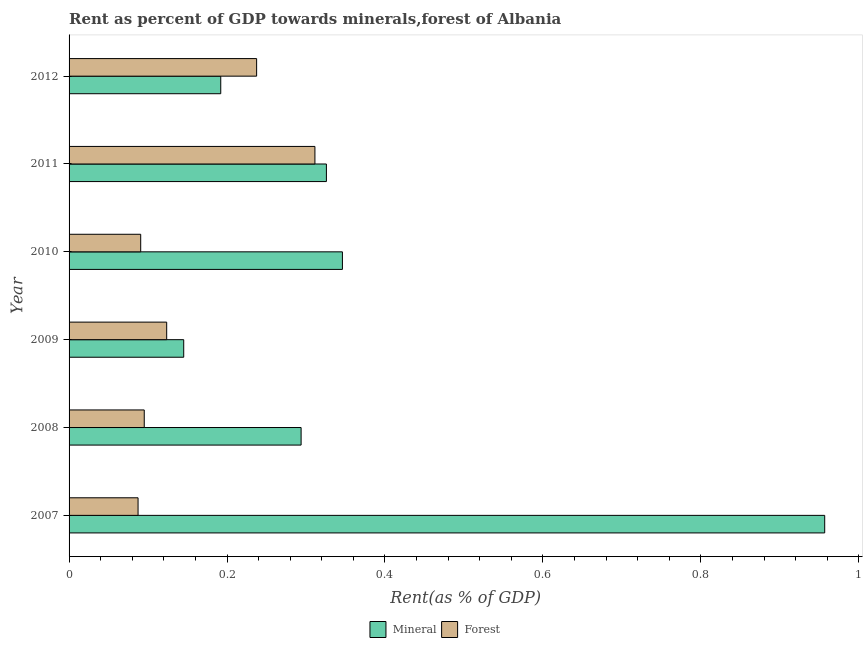How many different coloured bars are there?
Provide a succinct answer. 2. How many groups of bars are there?
Give a very brief answer. 6. Are the number of bars on each tick of the Y-axis equal?
Ensure brevity in your answer.  Yes. How many bars are there on the 3rd tick from the top?
Give a very brief answer. 2. How many bars are there on the 2nd tick from the bottom?
Ensure brevity in your answer.  2. In how many cases, is the number of bars for a given year not equal to the number of legend labels?
Your answer should be very brief. 0. What is the mineral rent in 2008?
Keep it short and to the point. 0.29. Across all years, what is the maximum forest rent?
Offer a terse response. 0.31. Across all years, what is the minimum mineral rent?
Your answer should be compact. 0.15. What is the total mineral rent in the graph?
Your response must be concise. 2.26. What is the difference between the forest rent in 2007 and that in 2012?
Your answer should be compact. -0.15. What is the difference between the mineral rent in 2012 and the forest rent in 2010?
Offer a terse response. 0.1. What is the average forest rent per year?
Offer a terse response. 0.16. In the year 2011, what is the difference between the mineral rent and forest rent?
Your answer should be compact. 0.01. What is the ratio of the mineral rent in 2008 to that in 2010?
Your answer should be compact. 0.85. Is the mineral rent in 2009 less than that in 2010?
Keep it short and to the point. Yes. Is the difference between the mineral rent in 2010 and 2012 greater than the difference between the forest rent in 2010 and 2012?
Offer a terse response. Yes. What is the difference between the highest and the second highest mineral rent?
Offer a very short reply. 0.61. What is the difference between the highest and the lowest mineral rent?
Provide a succinct answer. 0.81. In how many years, is the mineral rent greater than the average mineral rent taken over all years?
Offer a terse response. 1. Is the sum of the mineral rent in 2009 and 2012 greater than the maximum forest rent across all years?
Give a very brief answer. Yes. What does the 1st bar from the top in 2008 represents?
Your answer should be very brief. Forest. What does the 2nd bar from the bottom in 2008 represents?
Offer a very short reply. Forest. How many bars are there?
Your response must be concise. 12. How many years are there in the graph?
Offer a very short reply. 6. Are the values on the major ticks of X-axis written in scientific E-notation?
Ensure brevity in your answer.  No. Does the graph contain any zero values?
Ensure brevity in your answer.  No. Does the graph contain grids?
Make the answer very short. No. Where does the legend appear in the graph?
Give a very brief answer. Bottom center. How are the legend labels stacked?
Ensure brevity in your answer.  Horizontal. What is the title of the graph?
Keep it short and to the point. Rent as percent of GDP towards minerals,forest of Albania. What is the label or title of the X-axis?
Offer a very short reply. Rent(as % of GDP). What is the label or title of the Y-axis?
Your answer should be very brief. Year. What is the Rent(as % of GDP) in Mineral in 2007?
Provide a short and direct response. 0.96. What is the Rent(as % of GDP) of Forest in 2007?
Make the answer very short. 0.09. What is the Rent(as % of GDP) of Mineral in 2008?
Your response must be concise. 0.29. What is the Rent(as % of GDP) of Forest in 2008?
Your answer should be compact. 0.1. What is the Rent(as % of GDP) in Mineral in 2009?
Provide a short and direct response. 0.15. What is the Rent(as % of GDP) in Forest in 2009?
Offer a very short reply. 0.12. What is the Rent(as % of GDP) in Mineral in 2010?
Your answer should be compact. 0.35. What is the Rent(as % of GDP) in Forest in 2010?
Ensure brevity in your answer.  0.09. What is the Rent(as % of GDP) of Mineral in 2011?
Keep it short and to the point. 0.33. What is the Rent(as % of GDP) of Forest in 2011?
Your answer should be compact. 0.31. What is the Rent(as % of GDP) of Mineral in 2012?
Provide a short and direct response. 0.19. What is the Rent(as % of GDP) of Forest in 2012?
Provide a succinct answer. 0.24. Across all years, what is the maximum Rent(as % of GDP) of Mineral?
Your answer should be very brief. 0.96. Across all years, what is the maximum Rent(as % of GDP) in Forest?
Your answer should be very brief. 0.31. Across all years, what is the minimum Rent(as % of GDP) of Mineral?
Your answer should be very brief. 0.15. Across all years, what is the minimum Rent(as % of GDP) of Forest?
Your answer should be compact. 0.09. What is the total Rent(as % of GDP) in Mineral in the graph?
Your answer should be very brief. 2.26. What is the total Rent(as % of GDP) of Forest in the graph?
Keep it short and to the point. 0.95. What is the difference between the Rent(as % of GDP) in Mineral in 2007 and that in 2008?
Offer a terse response. 0.66. What is the difference between the Rent(as % of GDP) in Forest in 2007 and that in 2008?
Give a very brief answer. -0.01. What is the difference between the Rent(as % of GDP) of Mineral in 2007 and that in 2009?
Make the answer very short. 0.81. What is the difference between the Rent(as % of GDP) in Forest in 2007 and that in 2009?
Provide a short and direct response. -0.04. What is the difference between the Rent(as % of GDP) of Mineral in 2007 and that in 2010?
Your answer should be compact. 0.61. What is the difference between the Rent(as % of GDP) of Forest in 2007 and that in 2010?
Provide a short and direct response. -0. What is the difference between the Rent(as % of GDP) in Mineral in 2007 and that in 2011?
Your answer should be compact. 0.63. What is the difference between the Rent(as % of GDP) in Forest in 2007 and that in 2011?
Provide a short and direct response. -0.22. What is the difference between the Rent(as % of GDP) of Mineral in 2007 and that in 2012?
Keep it short and to the point. 0.76. What is the difference between the Rent(as % of GDP) of Forest in 2007 and that in 2012?
Keep it short and to the point. -0.15. What is the difference between the Rent(as % of GDP) in Mineral in 2008 and that in 2009?
Provide a short and direct response. 0.15. What is the difference between the Rent(as % of GDP) in Forest in 2008 and that in 2009?
Ensure brevity in your answer.  -0.03. What is the difference between the Rent(as % of GDP) of Mineral in 2008 and that in 2010?
Your response must be concise. -0.05. What is the difference between the Rent(as % of GDP) in Forest in 2008 and that in 2010?
Make the answer very short. 0. What is the difference between the Rent(as % of GDP) of Mineral in 2008 and that in 2011?
Make the answer very short. -0.03. What is the difference between the Rent(as % of GDP) in Forest in 2008 and that in 2011?
Offer a very short reply. -0.22. What is the difference between the Rent(as % of GDP) of Mineral in 2008 and that in 2012?
Offer a very short reply. 0.1. What is the difference between the Rent(as % of GDP) in Forest in 2008 and that in 2012?
Give a very brief answer. -0.14. What is the difference between the Rent(as % of GDP) of Mineral in 2009 and that in 2010?
Offer a very short reply. -0.2. What is the difference between the Rent(as % of GDP) in Forest in 2009 and that in 2010?
Make the answer very short. 0.03. What is the difference between the Rent(as % of GDP) in Mineral in 2009 and that in 2011?
Offer a terse response. -0.18. What is the difference between the Rent(as % of GDP) of Forest in 2009 and that in 2011?
Give a very brief answer. -0.19. What is the difference between the Rent(as % of GDP) in Mineral in 2009 and that in 2012?
Provide a succinct answer. -0.05. What is the difference between the Rent(as % of GDP) of Forest in 2009 and that in 2012?
Give a very brief answer. -0.11. What is the difference between the Rent(as % of GDP) in Mineral in 2010 and that in 2011?
Offer a very short reply. 0.02. What is the difference between the Rent(as % of GDP) of Forest in 2010 and that in 2011?
Offer a very short reply. -0.22. What is the difference between the Rent(as % of GDP) in Mineral in 2010 and that in 2012?
Provide a short and direct response. 0.15. What is the difference between the Rent(as % of GDP) of Forest in 2010 and that in 2012?
Your answer should be very brief. -0.15. What is the difference between the Rent(as % of GDP) in Mineral in 2011 and that in 2012?
Provide a short and direct response. 0.13. What is the difference between the Rent(as % of GDP) of Forest in 2011 and that in 2012?
Your response must be concise. 0.07. What is the difference between the Rent(as % of GDP) of Mineral in 2007 and the Rent(as % of GDP) of Forest in 2008?
Offer a very short reply. 0.86. What is the difference between the Rent(as % of GDP) in Mineral in 2007 and the Rent(as % of GDP) in Forest in 2009?
Your response must be concise. 0.83. What is the difference between the Rent(as % of GDP) of Mineral in 2007 and the Rent(as % of GDP) of Forest in 2010?
Give a very brief answer. 0.87. What is the difference between the Rent(as % of GDP) in Mineral in 2007 and the Rent(as % of GDP) in Forest in 2011?
Give a very brief answer. 0.65. What is the difference between the Rent(as % of GDP) of Mineral in 2007 and the Rent(as % of GDP) of Forest in 2012?
Your answer should be very brief. 0.72. What is the difference between the Rent(as % of GDP) in Mineral in 2008 and the Rent(as % of GDP) in Forest in 2009?
Keep it short and to the point. 0.17. What is the difference between the Rent(as % of GDP) in Mineral in 2008 and the Rent(as % of GDP) in Forest in 2010?
Your response must be concise. 0.2. What is the difference between the Rent(as % of GDP) of Mineral in 2008 and the Rent(as % of GDP) of Forest in 2011?
Keep it short and to the point. -0.02. What is the difference between the Rent(as % of GDP) in Mineral in 2008 and the Rent(as % of GDP) in Forest in 2012?
Keep it short and to the point. 0.06. What is the difference between the Rent(as % of GDP) of Mineral in 2009 and the Rent(as % of GDP) of Forest in 2010?
Offer a very short reply. 0.05. What is the difference between the Rent(as % of GDP) in Mineral in 2009 and the Rent(as % of GDP) in Forest in 2011?
Your answer should be very brief. -0.17. What is the difference between the Rent(as % of GDP) of Mineral in 2009 and the Rent(as % of GDP) of Forest in 2012?
Offer a very short reply. -0.09. What is the difference between the Rent(as % of GDP) in Mineral in 2010 and the Rent(as % of GDP) in Forest in 2011?
Your answer should be very brief. 0.03. What is the difference between the Rent(as % of GDP) in Mineral in 2010 and the Rent(as % of GDP) in Forest in 2012?
Provide a short and direct response. 0.11. What is the difference between the Rent(as % of GDP) of Mineral in 2011 and the Rent(as % of GDP) of Forest in 2012?
Your answer should be compact. 0.09. What is the average Rent(as % of GDP) in Mineral per year?
Offer a very short reply. 0.38. What is the average Rent(as % of GDP) of Forest per year?
Keep it short and to the point. 0.16. In the year 2007, what is the difference between the Rent(as % of GDP) of Mineral and Rent(as % of GDP) of Forest?
Provide a succinct answer. 0.87. In the year 2008, what is the difference between the Rent(as % of GDP) in Mineral and Rent(as % of GDP) in Forest?
Offer a terse response. 0.2. In the year 2009, what is the difference between the Rent(as % of GDP) in Mineral and Rent(as % of GDP) in Forest?
Your response must be concise. 0.02. In the year 2010, what is the difference between the Rent(as % of GDP) of Mineral and Rent(as % of GDP) of Forest?
Give a very brief answer. 0.26. In the year 2011, what is the difference between the Rent(as % of GDP) in Mineral and Rent(as % of GDP) in Forest?
Give a very brief answer. 0.01. In the year 2012, what is the difference between the Rent(as % of GDP) in Mineral and Rent(as % of GDP) in Forest?
Give a very brief answer. -0.05. What is the ratio of the Rent(as % of GDP) of Mineral in 2007 to that in 2008?
Your response must be concise. 3.26. What is the ratio of the Rent(as % of GDP) in Forest in 2007 to that in 2008?
Provide a succinct answer. 0.92. What is the ratio of the Rent(as % of GDP) in Mineral in 2007 to that in 2009?
Make the answer very short. 6.59. What is the ratio of the Rent(as % of GDP) in Forest in 2007 to that in 2009?
Give a very brief answer. 0.71. What is the ratio of the Rent(as % of GDP) in Mineral in 2007 to that in 2010?
Your answer should be very brief. 2.76. What is the ratio of the Rent(as % of GDP) in Forest in 2007 to that in 2010?
Your answer should be very brief. 0.96. What is the ratio of the Rent(as % of GDP) in Mineral in 2007 to that in 2011?
Provide a succinct answer. 2.94. What is the ratio of the Rent(as % of GDP) of Forest in 2007 to that in 2011?
Give a very brief answer. 0.28. What is the ratio of the Rent(as % of GDP) of Mineral in 2007 to that in 2012?
Provide a short and direct response. 4.98. What is the ratio of the Rent(as % of GDP) of Forest in 2007 to that in 2012?
Your answer should be very brief. 0.37. What is the ratio of the Rent(as % of GDP) of Mineral in 2008 to that in 2009?
Offer a very short reply. 2.02. What is the ratio of the Rent(as % of GDP) of Forest in 2008 to that in 2009?
Offer a very short reply. 0.77. What is the ratio of the Rent(as % of GDP) of Mineral in 2008 to that in 2010?
Make the answer very short. 0.85. What is the ratio of the Rent(as % of GDP) of Forest in 2008 to that in 2010?
Your response must be concise. 1.05. What is the ratio of the Rent(as % of GDP) in Mineral in 2008 to that in 2011?
Your answer should be compact. 0.9. What is the ratio of the Rent(as % of GDP) of Forest in 2008 to that in 2011?
Offer a very short reply. 0.31. What is the ratio of the Rent(as % of GDP) in Mineral in 2008 to that in 2012?
Provide a short and direct response. 1.53. What is the ratio of the Rent(as % of GDP) in Forest in 2008 to that in 2012?
Provide a short and direct response. 0.4. What is the ratio of the Rent(as % of GDP) in Mineral in 2009 to that in 2010?
Provide a short and direct response. 0.42. What is the ratio of the Rent(as % of GDP) in Forest in 2009 to that in 2010?
Your answer should be compact. 1.36. What is the ratio of the Rent(as % of GDP) of Mineral in 2009 to that in 2011?
Ensure brevity in your answer.  0.45. What is the ratio of the Rent(as % of GDP) in Forest in 2009 to that in 2011?
Ensure brevity in your answer.  0.4. What is the ratio of the Rent(as % of GDP) of Mineral in 2009 to that in 2012?
Offer a terse response. 0.76. What is the ratio of the Rent(as % of GDP) in Forest in 2009 to that in 2012?
Make the answer very short. 0.52. What is the ratio of the Rent(as % of GDP) of Mineral in 2010 to that in 2011?
Ensure brevity in your answer.  1.06. What is the ratio of the Rent(as % of GDP) in Forest in 2010 to that in 2011?
Provide a short and direct response. 0.29. What is the ratio of the Rent(as % of GDP) in Mineral in 2010 to that in 2012?
Provide a succinct answer. 1.8. What is the ratio of the Rent(as % of GDP) of Forest in 2010 to that in 2012?
Provide a short and direct response. 0.38. What is the ratio of the Rent(as % of GDP) of Mineral in 2011 to that in 2012?
Keep it short and to the point. 1.7. What is the ratio of the Rent(as % of GDP) of Forest in 2011 to that in 2012?
Provide a short and direct response. 1.31. What is the difference between the highest and the second highest Rent(as % of GDP) of Mineral?
Your response must be concise. 0.61. What is the difference between the highest and the second highest Rent(as % of GDP) in Forest?
Offer a very short reply. 0.07. What is the difference between the highest and the lowest Rent(as % of GDP) in Mineral?
Make the answer very short. 0.81. What is the difference between the highest and the lowest Rent(as % of GDP) in Forest?
Your answer should be compact. 0.22. 